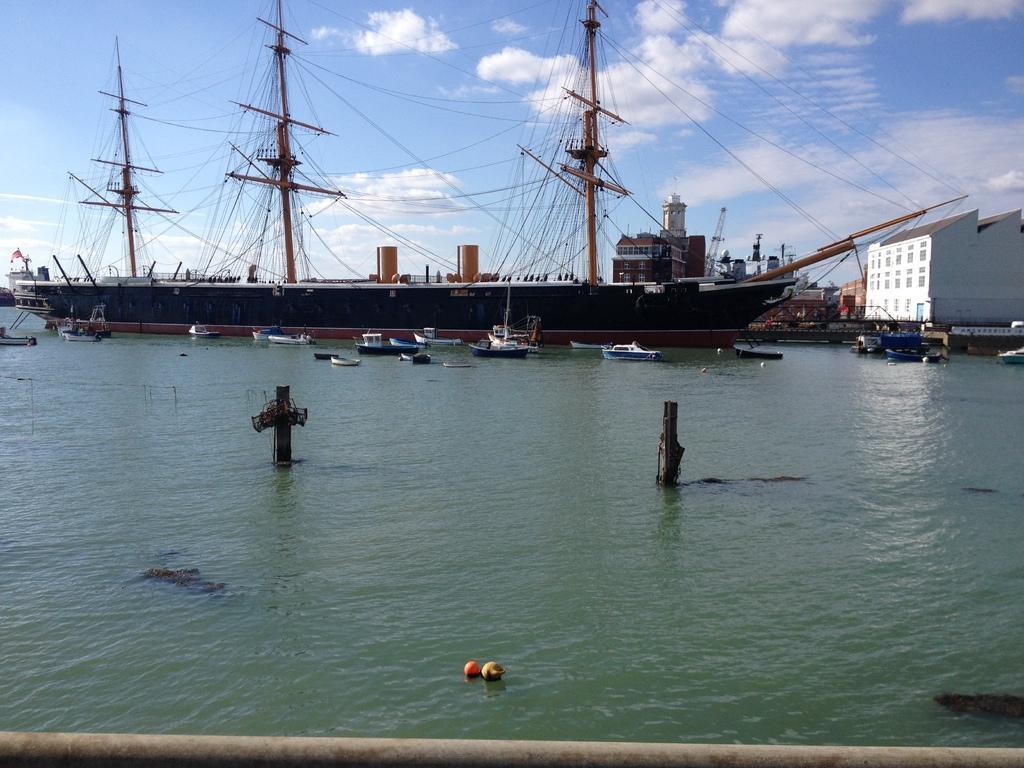Describe this image in one or two sentences. In this image in the middle, there are many boats, water. In the background there are many buildings, boats, sky and clouds. 